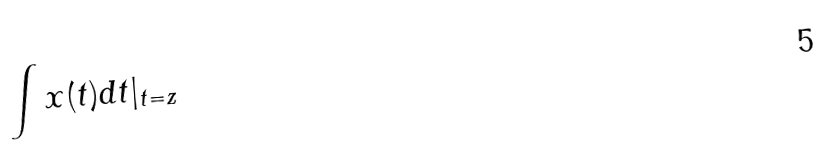<formula> <loc_0><loc_0><loc_500><loc_500>\int x ( t ) d t | _ { t = z }</formula> 